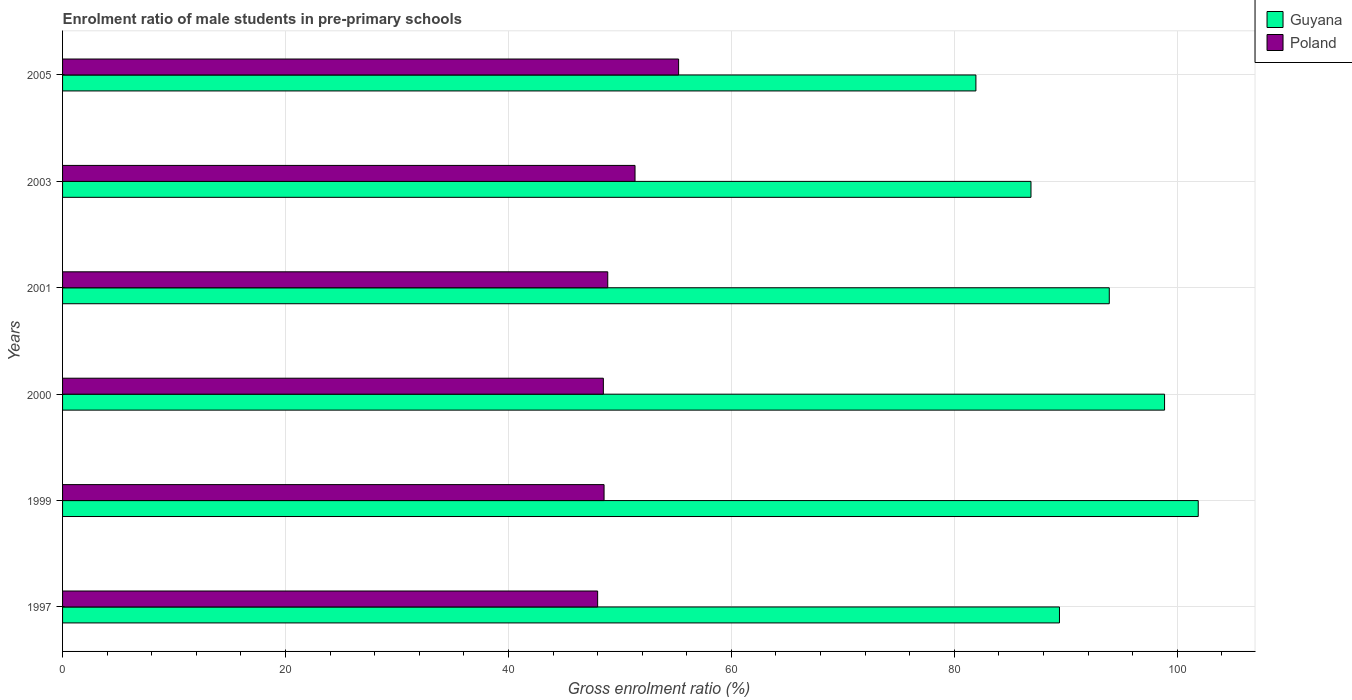How many different coloured bars are there?
Your response must be concise. 2. Are the number of bars per tick equal to the number of legend labels?
Your answer should be very brief. Yes. Are the number of bars on each tick of the Y-axis equal?
Your answer should be compact. Yes. What is the enrolment ratio of male students in pre-primary schools in Guyana in 2001?
Make the answer very short. 93.9. Across all years, what is the maximum enrolment ratio of male students in pre-primary schools in Poland?
Offer a very short reply. 55.27. Across all years, what is the minimum enrolment ratio of male students in pre-primary schools in Poland?
Provide a short and direct response. 48. In which year was the enrolment ratio of male students in pre-primary schools in Guyana minimum?
Offer a terse response. 2005. What is the total enrolment ratio of male students in pre-primary schools in Poland in the graph?
Offer a very short reply. 300.63. What is the difference between the enrolment ratio of male students in pre-primary schools in Poland in 1997 and that in 2001?
Your answer should be compact. -0.91. What is the difference between the enrolment ratio of male students in pre-primary schools in Guyana in 1997 and the enrolment ratio of male students in pre-primary schools in Poland in 2003?
Offer a terse response. 38.08. What is the average enrolment ratio of male students in pre-primary schools in Guyana per year?
Make the answer very short. 92.15. In the year 1999, what is the difference between the enrolment ratio of male students in pre-primary schools in Guyana and enrolment ratio of male students in pre-primary schools in Poland?
Your answer should be compact. 53.31. In how many years, is the enrolment ratio of male students in pre-primary schools in Guyana greater than 24 %?
Keep it short and to the point. 6. What is the ratio of the enrolment ratio of male students in pre-primary schools in Poland in 1999 to that in 2001?
Provide a short and direct response. 0.99. Is the enrolment ratio of male students in pre-primary schools in Poland in 1997 less than that in 2005?
Give a very brief answer. Yes. What is the difference between the highest and the second highest enrolment ratio of male students in pre-primary schools in Guyana?
Give a very brief answer. 3.02. What is the difference between the highest and the lowest enrolment ratio of male students in pre-primary schools in Guyana?
Provide a succinct answer. 19.95. Is the sum of the enrolment ratio of male students in pre-primary schools in Poland in 1997 and 2005 greater than the maximum enrolment ratio of male students in pre-primary schools in Guyana across all years?
Provide a succinct answer. Yes. What does the 1st bar from the bottom in 2000 represents?
Give a very brief answer. Guyana. How many bars are there?
Offer a terse response. 12. What is the difference between two consecutive major ticks on the X-axis?
Keep it short and to the point. 20. Are the values on the major ticks of X-axis written in scientific E-notation?
Your answer should be compact. No. Where does the legend appear in the graph?
Give a very brief answer. Top right. How many legend labels are there?
Offer a terse response. 2. What is the title of the graph?
Your answer should be very brief. Enrolment ratio of male students in pre-primary schools. What is the label or title of the Y-axis?
Your answer should be very brief. Years. What is the Gross enrolment ratio (%) of Guyana in 1997?
Make the answer very short. 89.43. What is the Gross enrolment ratio (%) in Poland in 1997?
Keep it short and to the point. 48. What is the Gross enrolment ratio (%) of Guyana in 1999?
Ensure brevity in your answer.  101.88. What is the Gross enrolment ratio (%) of Poland in 1999?
Offer a very short reply. 48.58. What is the Gross enrolment ratio (%) in Guyana in 2000?
Your response must be concise. 98.86. What is the Gross enrolment ratio (%) of Poland in 2000?
Make the answer very short. 48.52. What is the Gross enrolment ratio (%) of Guyana in 2001?
Your response must be concise. 93.9. What is the Gross enrolment ratio (%) of Poland in 2001?
Give a very brief answer. 48.91. What is the Gross enrolment ratio (%) in Guyana in 2003?
Provide a succinct answer. 86.88. What is the Gross enrolment ratio (%) in Poland in 2003?
Provide a short and direct response. 51.36. What is the Gross enrolment ratio (%) of Guyana in 2005?
Offer a very short reply. 81.94. What is the Gross enrolment ratio (%) of Poland in 2005?
Ensure brevity in your answer.  55.27. Across all years, what is the maximum Gross enrolment ratio (%) in Guyana?
Keep it short and to the point. 101.88. Across all years, what is the maximum Gross enrolment ratio (%) in Poland?
Keep it short and to the point. 55.27. Across all years, what is the minimum Gross enrolment ratio (%) of Guyana?
Provide a succinct answer. 81.94. Across all years, what is the minimum Gross enrolment ratio (%) of Poland?
Provide a short and direct response. 48. What is the total Gross enrolment ratio (%) in Guyana in the graph?
Provide a short and direct response. 552.91. What is the total Gross enrolment ratio (%) of Poland in the graph?
Provide a short and direct response. 300.63. What is the difference between the Gross enrolment ratio (%) of Guyana in 1997 and that in 1999?
Provide a succinct answer. -12.45. What is the difference between the Gross enrolment ratio (%) of Poland in 1997 and that in 1999?
Your answer should be very brief. -0.58. What is the difference between the Gross enrolment ratio (%) in Guyana in 1997 and that in 2000?
Your response must be concise. -9.43. What is the difference between the Gross enrolment ratio (%) in Poland in 1997 and that in 2000?
Keep it short and to the point. -0.51. What is the difference between the Gross enrolment ratio (%) in Guyana in 1997 and that in 2001?
Ensure brevity in your answer.  -4.47. What is the difference between the Gross enrolment ratio (%) of Poland in 1997 and that in 2001?
Provide a short and direct response. -0.91. What is the difference between the Gross enrolment ratio (%) of Guyana in 1997 and that in 2003?
Your answer should be very brief. 2.55. What is the difference between the Gross enrolment ratio (%) in Poland in 1997 and that in 2003?
Provide a short and direct response. -3.35. What is the difference between the Gross enrolment ratio (%) in Guyana in 1997 and that in 2005?
Make the answer very short. 7.5. What is the difference between the Gross enrolment ratio (%) in Poland in 1997 and that in 2005?
Keep it short and to the point. -7.26. What is the difference between the Gross enrolment ratio (%) of Guyana in 1999 and that in 2000?
Provide a succinct answer. 3.02. What is the difference between the Gross enrolment ratio (%) in Poland in 1999 and that in 2000?
Offer a very short reply. 0.06. What is the difference between the Gross enrolment ratio (%) in Guyana in 1999 and that in 2001?
Keep it short and to the point. 7.98. What is the difference between the Gross enrolment ratio (%) in Poland in 1999 and that in 2001?
Keep it short and to the point. -0.33. What is the difference between the Gross enrolment ratio (%) in Guyana in 1999 and that in 2003?
Offer a terse response. 15. What is the difference between the Gross enrolment ratio (%) of Poland in 1999 and that in 2003?
Provide a succinct answer. -2.78. What is the difference between the Gross enrolment ratio (%) of Guyana in 1999 and that in 2005?
Offer a very short reply. 19.95. What is the difference between the Gross enrolment ratio (%) of Poland in 1999 and that in 2005?
Offer a terse response. -6.69. What is the difference between the Gross enrolment ratio (%) of Guyana in 2000 and that in 2001?
Give a very brief answer. 4.96. What is the difference between the Gross enrolment ratio (%) of Poland in 2000 and that in 2001?
Provide a short and direct response. -0.39. What is the difference between the Gross enrolment ratio (%) in Guyana in 2000 and that in 2003?
Provide a short and direct response. 11.98. What is the difference between the Gross enrolment ratio (%) in Poland in 2000 and that in 2003?
Offer a terse response. -2.84. What is the difference between the Gross enrolment ratio (%) in Guyana in 2000 and that in 2005?
Your response must be concise. 16.93. What is the difference between the Gross enrolment ratio (%) of Poland in 2000 and that in 2005?
Offer a very short reply. -6.75. What is the difference between the Gross enrolment ratio (%) in Guyana in 2001 and that in 2003?
Make the answer very short. 7.02. What is the difference between the Gross enrolment ratio (%) in Poland in 2001 and that in 2003?
Give a very brief answer. -2.45. What is the difference between the Gross enrolment ratio (%) of Guyana in 2001 and that in 2005?
Make the answer very short. 11.97. What is the difference between the Gross enrolment ratio (%) in Poland in 2001 and that in 2005?
Offer a very short reply. -6.36. What is the difference between the Gross enrolment ratio (%) of Guyana in 2003 and that in 2005?
Keep it short and to the point. 4.94. What is the difference between the Gross enrolment ratio (%) in Poland in 2003 and that in 2005?
Offer a terse response. -3.91. What is the difference between the Gross enrolment ratio (%) in Guyana in 1997 and the Gross enrolment ratio (%) in Poland in 1999?
Give a very brief answer. 40.86. What is the difference between the Gross enrolment ratio (%) of Guyana in 1997 and the Gross enrolment ratio (%) of Poland in 2000?
Your answer should be compact. 40.92. What is the difference between the Gross enrolment ratio (%) in Guyana in 1997 and the Gross enrolment ratio (%) in Poland in 2001?
Ensure brevity in your answer.  40.52. What is the difference between the Gross enrolment ratio (%) in Guyana in 1997 and the Gross enrolment ratio (%) in Poland in 2003?
Provide a succinct answer. 38.08. What is the difference between the Gross enrolment ratio (%) of Guyana in 1997 and the Gross enrolment ratio (%) of Poland in 2005?
Provide a succinct answer. 34.17. What is the difference between the Gross enrolment ratio (%) in Guyana in 1999 and the Gross enrolment ratio (%) in Poland in 2000?
Ensure brevity in your answer.  53.37. What is the difference between the Gross enrolment ratio (%) of Guyana in 1999 and the Gross enrolment ratio (%) of Poland in 2001?
Offer a very short reply. 52.98. What is the difference between the Gross enrolment ratio (%) in Guyana in 1999 and the Gross enrolment ratio (%) in Poland in 2003?
Your response must be concise. 50.53. What is the difference between the Gross enrolment ratio (%) in Guyana in 1999 and the Gross enrolment ratio (%) in Poland in 2005?
Your answer should be very brief. 46.62. What is the difference between the Gross enrolment ratio (%) in Guyana in 2000 and the Gross enrolment ratio (%) in Poland in 2001?
Give a very brief answer. 49.95. What is the difference between the Gross enrolment ratio (%) in Guyana in 2000 and the Gross enrolment ratio (%) in Poland in 2003?
Ensure brevity in your answer.  47.51. What is the difference between the Gross enrolment ratio (%) of Guyana in 2000 and the Gross enrolment ratio (%) of Poland in 2005?
Offer a very short reply. 43.6. What is the difference between the Gross enrolment ratio (%) in Guyana in 2001 and the Gross enrolment ratio (%) in Poland in 2003?
Provide a succinct answer. 42.55. What is the difference between the Gross enrolment ratio (%) of Guyana in 2001 and the Gross enrolment ratio (%) of Poland in 2005?
Your response must be concise. 38.64. What is the difference between the Gross enrolment ratio (%) in Guyana in 2003 and the Gross enrolment ratio (%) in Poland in 2005?
Your answer should be very brief. 31.61. What is the average Gross enrolment ratio (%) of Guyana per year?
Offer a terse response. 92.15. What is the average Gross enrolment ratio (%) in Poland per year?
Your answer should be very brief. 50.11. In the year 1997, what is the difference between the Gross enrolment ratio (%) in Guyana and Gross enrolment ratio (%) in Poland?
Make the answer very short. 41.43. In the year 1999, what is the difference between the Gross enrolment ratio (%) of Guyana and Gross enrolment ratio (%) of Poland?
Offer a very short reply. 53.31. In the year 2000, what is the difference between the Gross enrolment ratio (%) of Guyana and Gross enrolment ratio (%) of Poland?
Your answer should be very brief. 50.35. In the year 2001, what is the difference between the Gross enrolment ratio (%) in Guyana and Gross enrolment ratio (%) in Poland?
Provide a succinct answer. 44.99. In the year 2003, what is the difference between the Gross enrolment ratio (%) of Guyana and Gross enrolment ratio (%) of Poland?
Make the answer very short. 35.52. In the year 2005, what is the difference between the Gross enrolment ratio (%) of Guyana and Gross enrolment ratio (%) of Poland?
Your answer should be very brief. 26.67. What is the ratio of the Gross enrolment ratio (%) of Guyana in 1997 to that in 1999?
Make the answer very short. 0.88. What is the ratio of the Gross enrolment ratio (%) of Guyana in 1997 to that in 2000?
Offer a terse response. 0.9. What is the ratio of the Gross enrolment ratio (%) in Guyana in 1997 to that in 2001?
Give a very brief answer. 0.95. What is the ratio of the Gross enrolment ratio (%) of Poland in 1997 to that in 2001?
Provide a succinct answer. 0.98. What is the ratio of the Gross enrolment ratio (%) of Guyana in 1997 to that in 2003?
Give a very brief answer. 1.03. What is the ratio of the Gross enrolment ratio (%) of Poland in 1997 to that in 2003?
Give a very brief answer. 0.93. What is the ratio of the Gross enrolment ratio (%) of Guyana in 1997 to that in 2005?
Offer a terse response. 1.09. What is the ratio of the Gross enrolment ratio (%) in Poland in 1997 to that in 2005?
Keep it short and to the point. 0.87. What is the ratio of the Gross enrolment ratio (%) in Guyana in 1999 to that in 2000?
Your answer should be very brief. 1.03. What is the ratio of the Gross enrolment ratio (%) of Poland in 1999 to that in 2000?
Give a very brief answer. 1. What is the ratio of the Gross enrolment ratio (%) in Guyana in 1999 to that in 2001?
Provide a short and direct response. 1.08. What is the ratio of the Gross enrolment ratio (%) in Poland in 1999 to that in 2001?
Provide a succinct answer. 0.99. What is the ratio of the Gross enrolment ratio (%) in Guyana in 1999 to that in 2003?
Keep it short and to the point. 1.17. What is the ratio of the Gross enrolment ratio (%) of Poland in 1999 to that in 2003?
Your answer should be compact. 0.95. What is the ratio of the Gross enrolment ratio (%) of Guyana in 1999 to that in 2005?
Give a very brief answer. 1.24. What is the ratio of the Gross enrolment ratio (%) in Poland in 1999 to that in 2005?
Your answer should be compact. 0.88. What is the ratio of the Gross enrolment ratio (%) of Guyana in 2000 to that in 2001?
Offer a terse response. 1.05. What is the ratio of the Gross enrolment ratio (%) of Poland in 2000 to that in 2001?
Offer a terse response. 0.99. What is the ratio of the Gross enrolment ratio (%) of Guyana in 2000 to that in 2003?
Offer a very short reply. 1.14. What is the ratio of the Gross enrolment ratio (%) of Poland in 2000 to that in 2003?
Provide a succinct answer. 0.94. What is the ratio of the Gross enrolment ratio (%) of Guyana in 2000 to that in 2005?
Offer a terse response. 1.21. What is the ratio of the Gross enrolment ratio (%) in Poland in 2000 to that in 2005?
Provide a short and direct response. 0.88. What is the ratio of the Gross enrolment ratio (%) of Guyana in 2001 to that in 2003?
Ensure brevity in your answer.  1.08. What is the ratio of the Gross enrolment ratio (%) of Poland in 2001 to that in 2003?
Your answer should be compact. 0.95. What is the ratio of the Gross enrolment ratio (%) in Guyana in 2001 to that in 2005?
Provide a short and direct response. 1.15. What is the ratio of the Gross enrolment ratio (%) of Poland in 2001 to that in 2005?
Your answer should be compact. 0.89. What is the ratio of the Gross enrolment ratio (%) of Guyana in 2003 to that in 2005?
Make the answer very short. 1.06. What is the ratio of the Gross enrolment ratio (%) in Poland in 2003 to that in 2005?
Your answer should be compact. 0.93. What is the difference between the highest and the second highest Gross enrolment ratio (%) in Guyana?
Provide a succinct answer. 3.02. What is the difference between the highest and the second highest Gross enrolment ratio (%) of Poland?
Offer a very short reply. 3.91. What is the difference between the highest and the lowest Gross enrolment ratio (%) of Guyana?
Your answer should be compact. 19.95. What is the difference between the highest and the lowest Gross enrolment ratio (%) of Poland?
Offer a terse response. 7.26. 